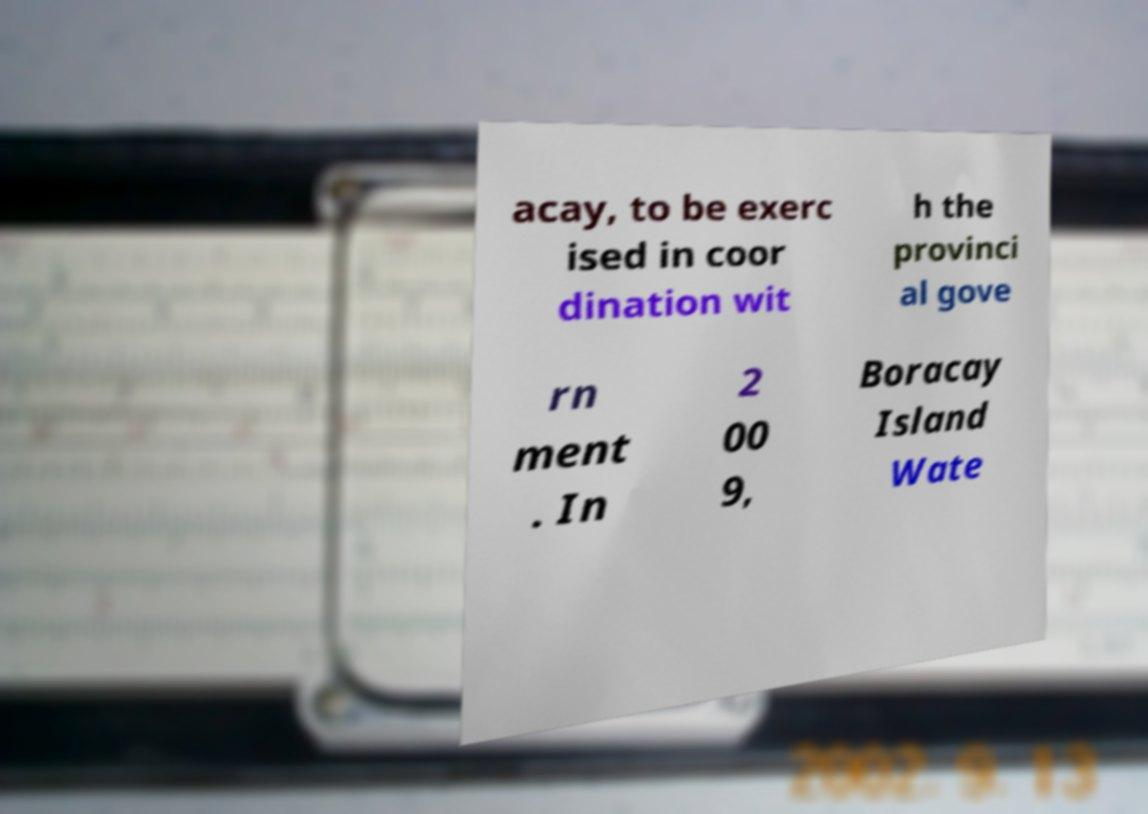Can you accurately transcribe the text from the provided image for me? acay, to be exerc ised in coor dination wit h the provinci al gove rn ment . In 2 00 9, Boracay Island Wate 